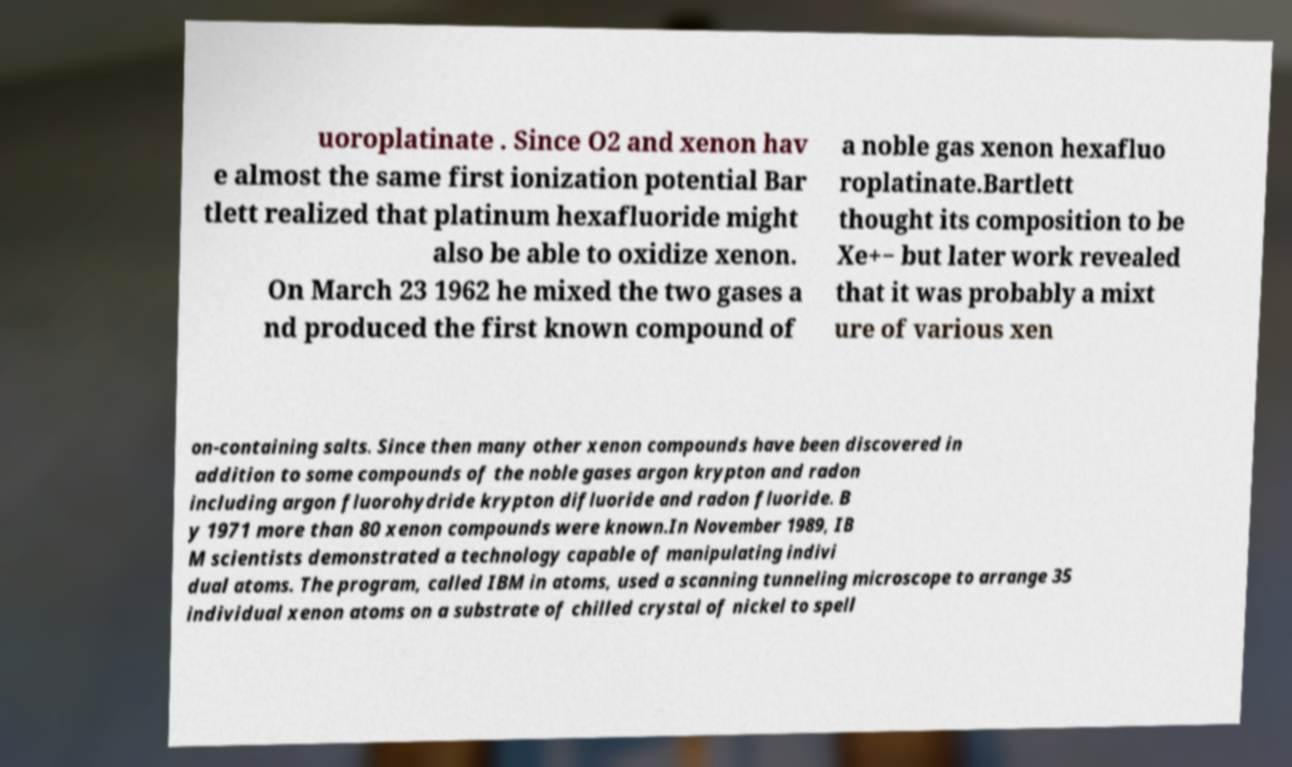Can you read and provide the text displayed in the image?This photo seems to have some interesting text. Can you extract and type it out for me? uoroplatinate . Since O2 and xenon hav e almost the same first ionization potential Bar tlett realized that platinum hexafluoride might also be able to oxidize xenon. On March 23 1962 he mixed the two gases a nd produced the first known compound of a noble gas xenon hexafluo roplatinate.Bartlett thought its composition to be Xe+− but later work revealed that it was probably a mixt ure of various xen on-containing salts. Since then many other xenon compounds have been discovered in addition to some compounds of the noble gases argon krypton and radon including argon fluorohydride krypton difluoride and radon fluoride. B y 1971 more than 80 xenon compounds were known.In November 1989, IB M scientists demonstrated a technology capable of manipulating indivi dual atoms. The program, called IBM in atoms, used a scanning tunneling microscope to arrange 35 individual xenon atoms on a substrate of chilled crystal of nickel to spell 